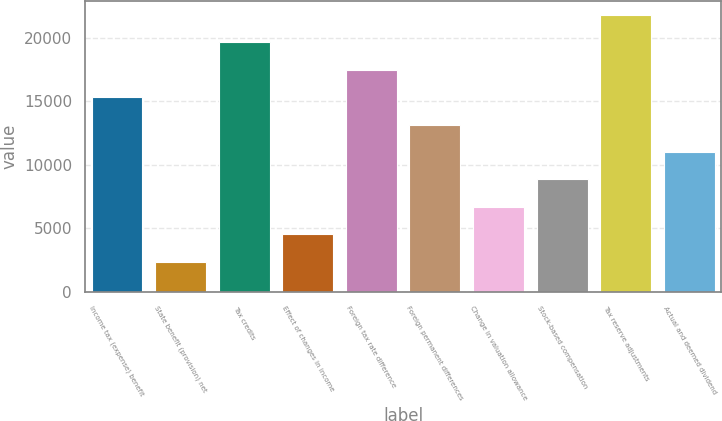<chart> <loc_0><loc_0><loc_500><loc_500><bar_chart><fcel>Income tax (expense) benefit<fcel>State benefit (provision) net<fcel>Tax credits<fcel>Effect of changes in income<fcel>Foreign tax rate difference<fcel>Foreign permanent differences<fcel>Change in valuation allowance<fcel>Stock-based compensation<fcel>Tax reserve adjustments<fcel>Actual and deemed dividend<nl><fcel>15316.5<fcel>2371.5<fcel>19631.5<fcel>4529<fcel>17474<fcel>13159<fcel>6686.5<fcel>8844<fcel>21789<fcel>11001.5<nl></chart> 